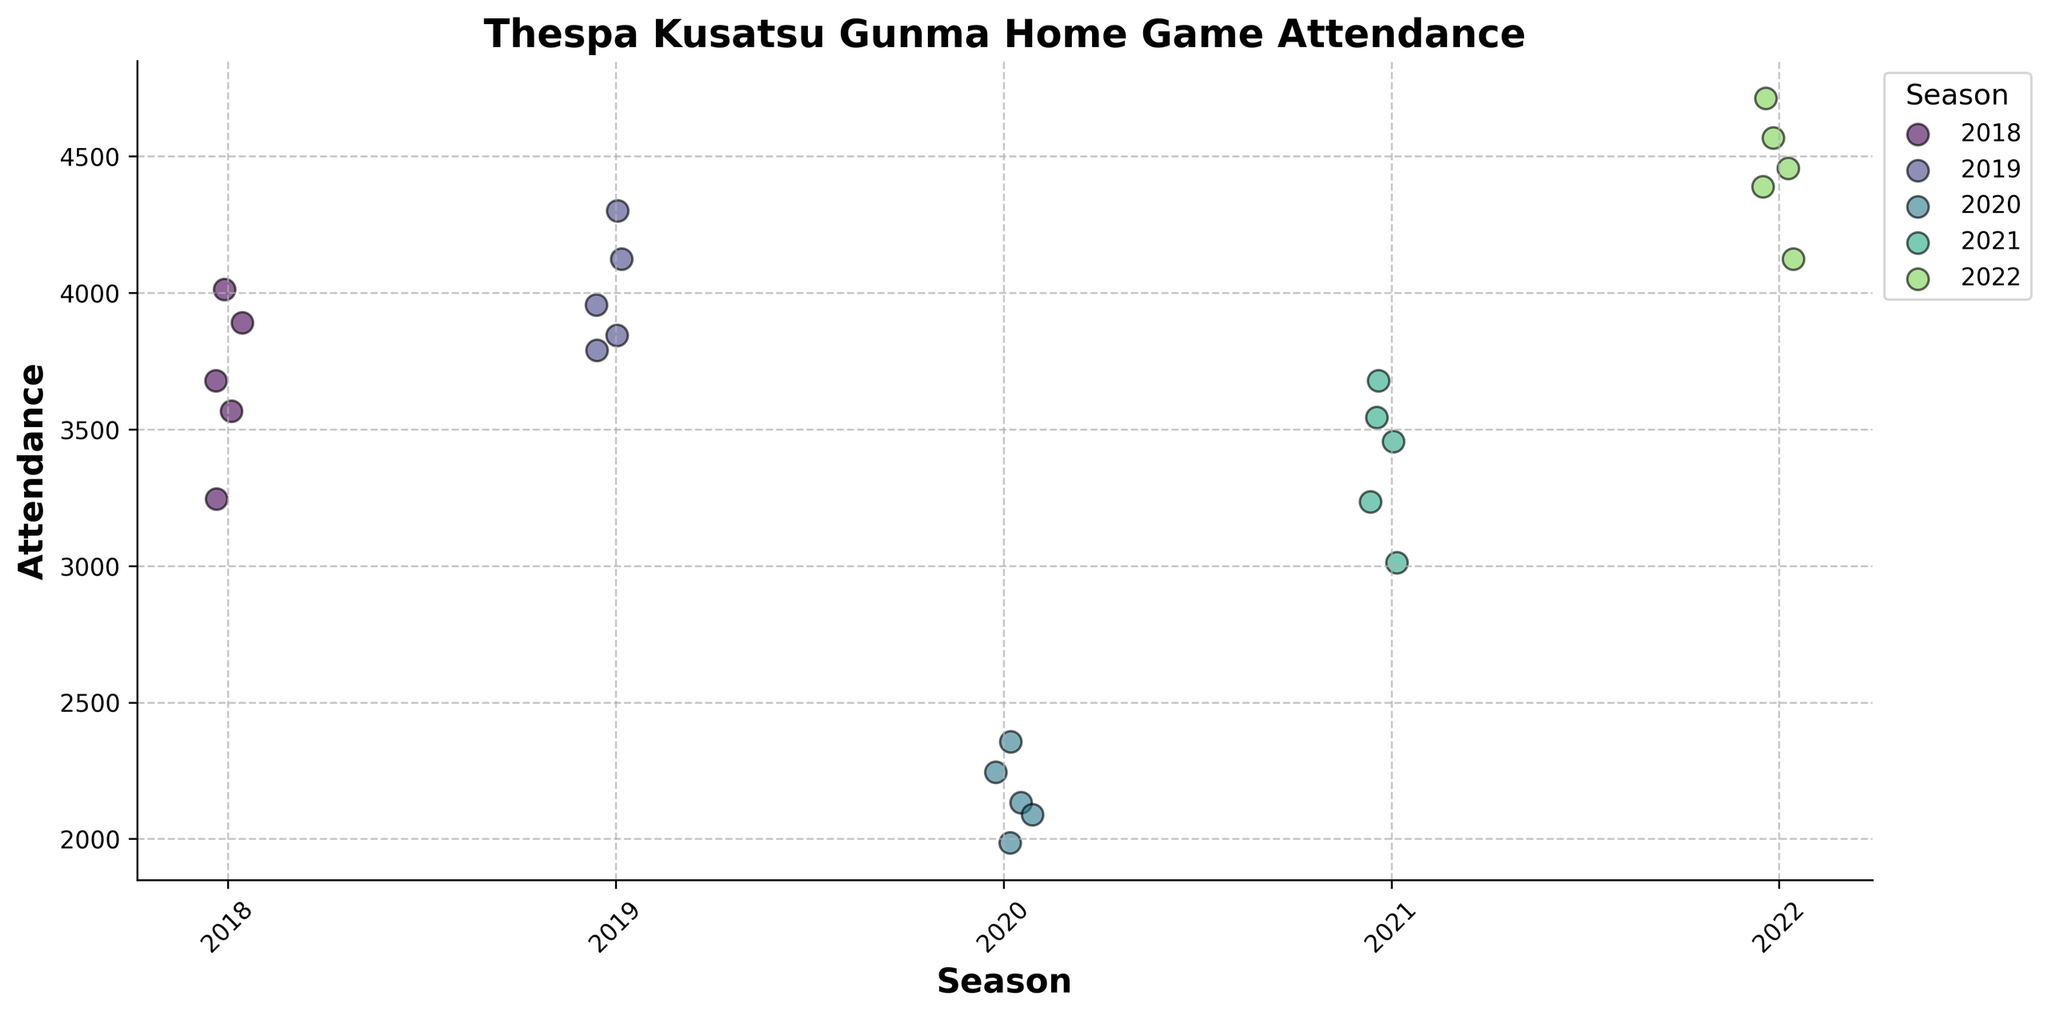How many seasons are represented in the plot? The plot shows attendance data for multiple seasons. By observing the different colors and the legend, you can count the unique seasons displayed.
Answer: 5 What is the title of the plot? The title of the plot is usually found at the top of the figure. In this case, it reads as given in the code snippet provided.
Answer: Thespa Kusatsu Gunma Home Game Attendance Which season has the highest attendance? The season with the highest attendance can be found by locating the dots plotted at the highest position on the y-axis.
Answer: 2022 What is the range of attendance figures for the 2020 season? To find the range, identify the highest and lowest attendance values for the 2020 season and subtract the lowest value from the highest value. In 2020, the highest is 2356 and the lowest is 1987. The range is 2356 - 1987.
Answer: 369 How did the attendance figures change from 2018 to 2020? Look at the general position of the data points for 2018 and compare them to those of 2020. 2018 has higher values overall compared to the much lower values in 2020.
Answer: The attendance decreased What is the average attendance for the 2021 season? Identify all attendance values for the 2021 season, sum them up, and divide by the number of values. The values are 3012, 3456, 3234, 3678, 3543. The total is 16923. There are 5 values, so 16923/5.
Answer: 3384.6 Which season has the greatest variability in attendance figures? Variability can be visualized by the spread of the data points. The season with the widest spread of points along the y-axis indicates the greatest variability.
Answer: 2022 How many home games were recorded for each season? The number of home games is equal to the number of data points for each season. Count the points for each group that is clustered around each season's labeled position on the x-axis.
Answer: 5 Compare the highest attendance in 2019 to the highest attendance in 2018. Which is greater? Identify the highest points for both seasons. The highest attendance in 2019 is 4301 and in 2018 is 4012.
Answer: 2019 What is the median attendance value for the 2020 season? To find the median, arrange the 2020 attendance values in order and select the middle one. The values are 1987, 2089, 2134, 2245, 2356. The median is the middle value.
Answer: 2134 